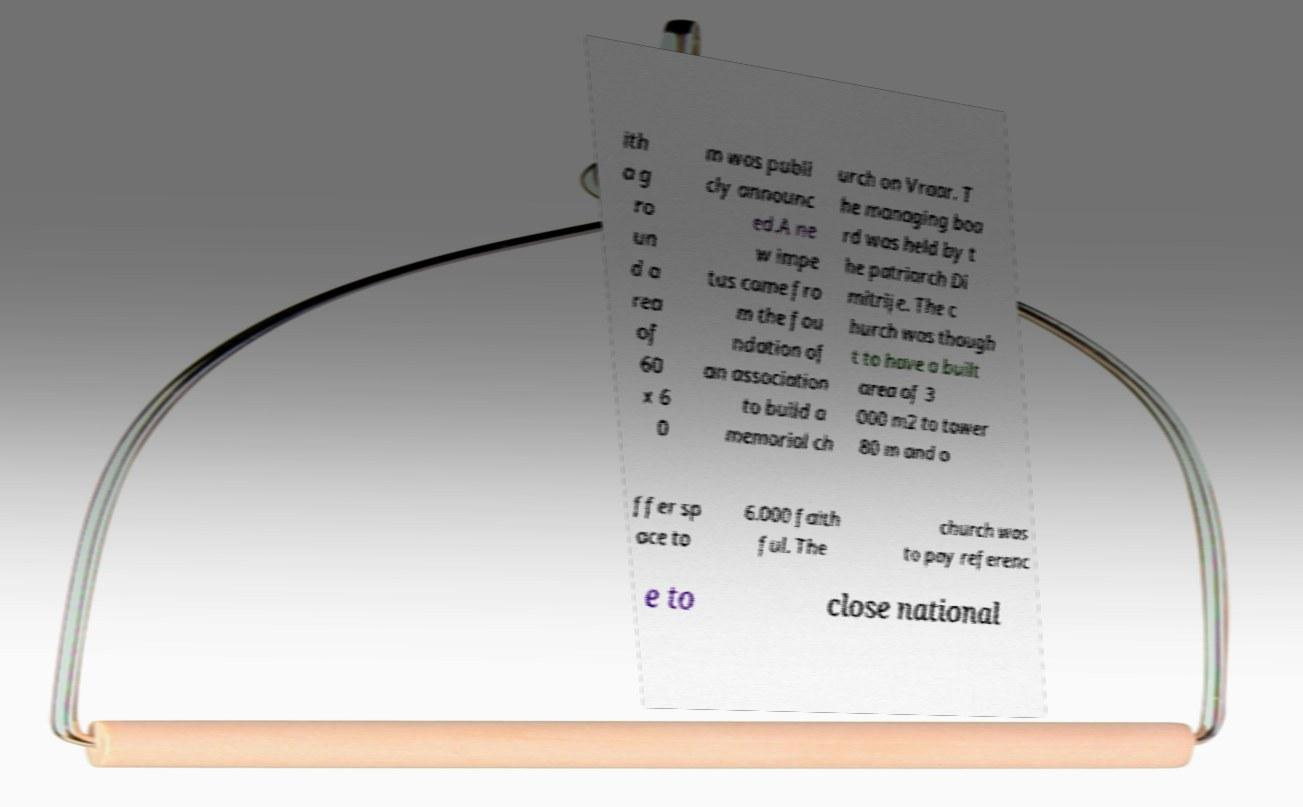For documentation purposes, I need the text within this image transcribed. Could you provide that? ith a g ro un d a rea of 60 x 6 0 m was publi cly announc ed.A ne w impe tus came fro m the fou ndation of an association to build a memorial ch urch on Vraar. T he managing boa rd was held by t he patriarch Di mitrije. The c hurch was though t to have a built area of 3 000 m2 to tower 80 m and o ffer sp ace to 6.000 faith ful. The church was to pay referenc e to close national 